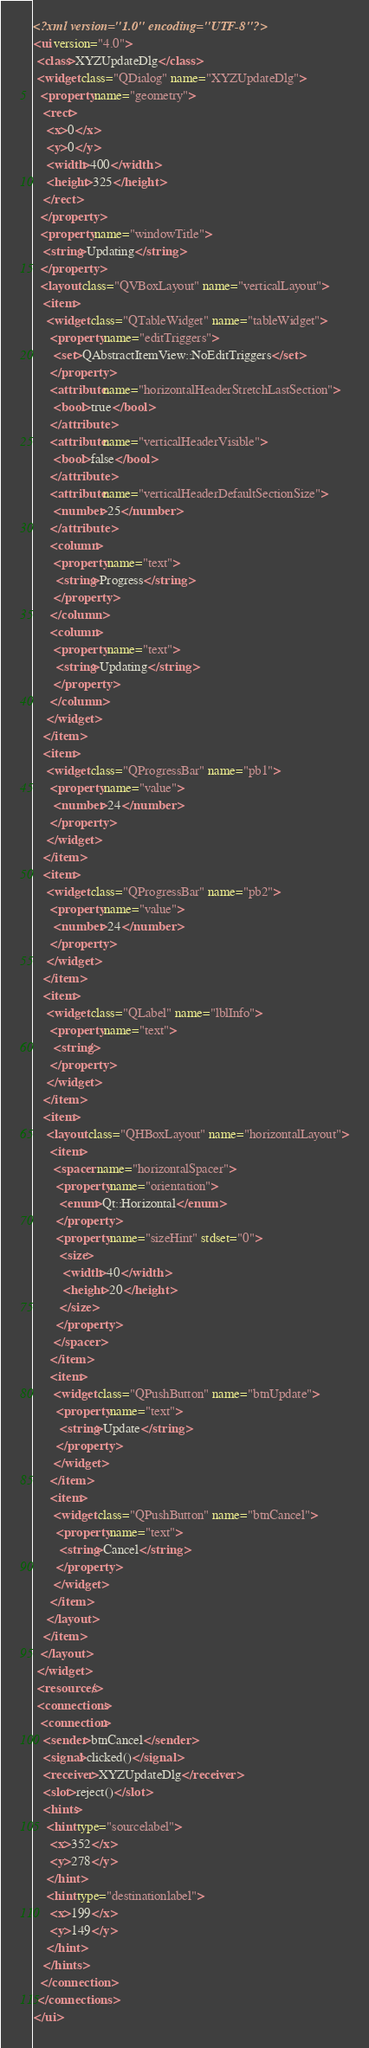Convert code to text. <code><loc_0><loc_0><loc_500><loc_500><_XML_><?xml version="1.0" encoding="UTF-8"?>
<ui version="4.0">
 <class>XYZUpdateDlg</class>
 <widget class="QDialog" name="XYZUpdateDlg">
  <property name="geometry">
   <rect>
    <x>0</x>
    <y>0</y>
    <width>400</width>
    <height>325</height>
   </rect>
  </property>
  <property name="windowTitle">
   <string>Updating</string>
  </property>
  <layout class="QVBoxLayout" name="verticalLayout">
   <item>
    <widget class="QTableWidget" name="tableWidget">
     <property name="editTriggers">
      <set>QAbstractItemView::NoEditTriggers</set>
     </property>
     <attribute name="horizontalHeaderStretchLastSection">
      <bool>true</bool>
     </attribute>
     <attribute name="verticalHeaderVisible">
      <bool>false</bool>
     </attribute>
     <attribute name="verticalHeaderDefaultSectionSize">
      <number>25</number>
     </attribute>
     <column>
      <property name="text">
       <string>Progress</string>
      </property>
     </column>
     <column>
      <property name="text">
       <string>Updating</string>
      </property>
     </column>
    </widget>
   </item>
   <item>
    <widget class="QProgressBar" name="pb1">
     <property name="value">
      <number>24</number>
     </property>
    </widget>
   </item>
   <item>
    <widget class="QProgressBar" name="pb2">
     <property name="value">
      <number>24</number>
     </property>
    </widget>
   </item>
   <item>
    <widget class="QLabel" name="lblInfo">
     <property name="text">
      <string/>
     </property>
    </widget>
   </item>
   <item>
    <layout class="QHBoxLayout" name="horizontalLayout">
     <item>
      <spacer name="horizontalSpacer">
       <property name="orientation">
        <enum>Qt::Horizontal</enum>
       </property>
       <property name="sizeHint" stdset="0">
        <size>
         <width>40</width>
         <height>20</height>
        </size>
       </property>
      </spacer>
     </item>
     <item>
      <widget class="QPushButton" name="btnUpdate">
       <property name="text">
        <string>Update</string>
       </property>
      </widget>
     </item>
     <item>
      <widget class="QPushButton" name="btnCancel">
       <property name="text">
        <string>Cancel</string>
       </property>
      </widget>
     </item>
    </layout>
   </item>
  </layout>
 </widget>
 <resources/>
 <connections>
  <connection>
   <sender>btnCancel</sender>
   <signal>clicked()</signal>
   <receiver>XYZUpdateDlg</receiver>
   <slot>reject()</slot>
   <hints>
    <hint type="sourcelabel">
     <x>352</x>
     <y>278</y>
    </hint>
    <hint type="destinationlabel">
     <x>199</x>
     <y>149</y>
    </hint>
   </hints>
  </connection>
 </connections>
</ui>
</code> 